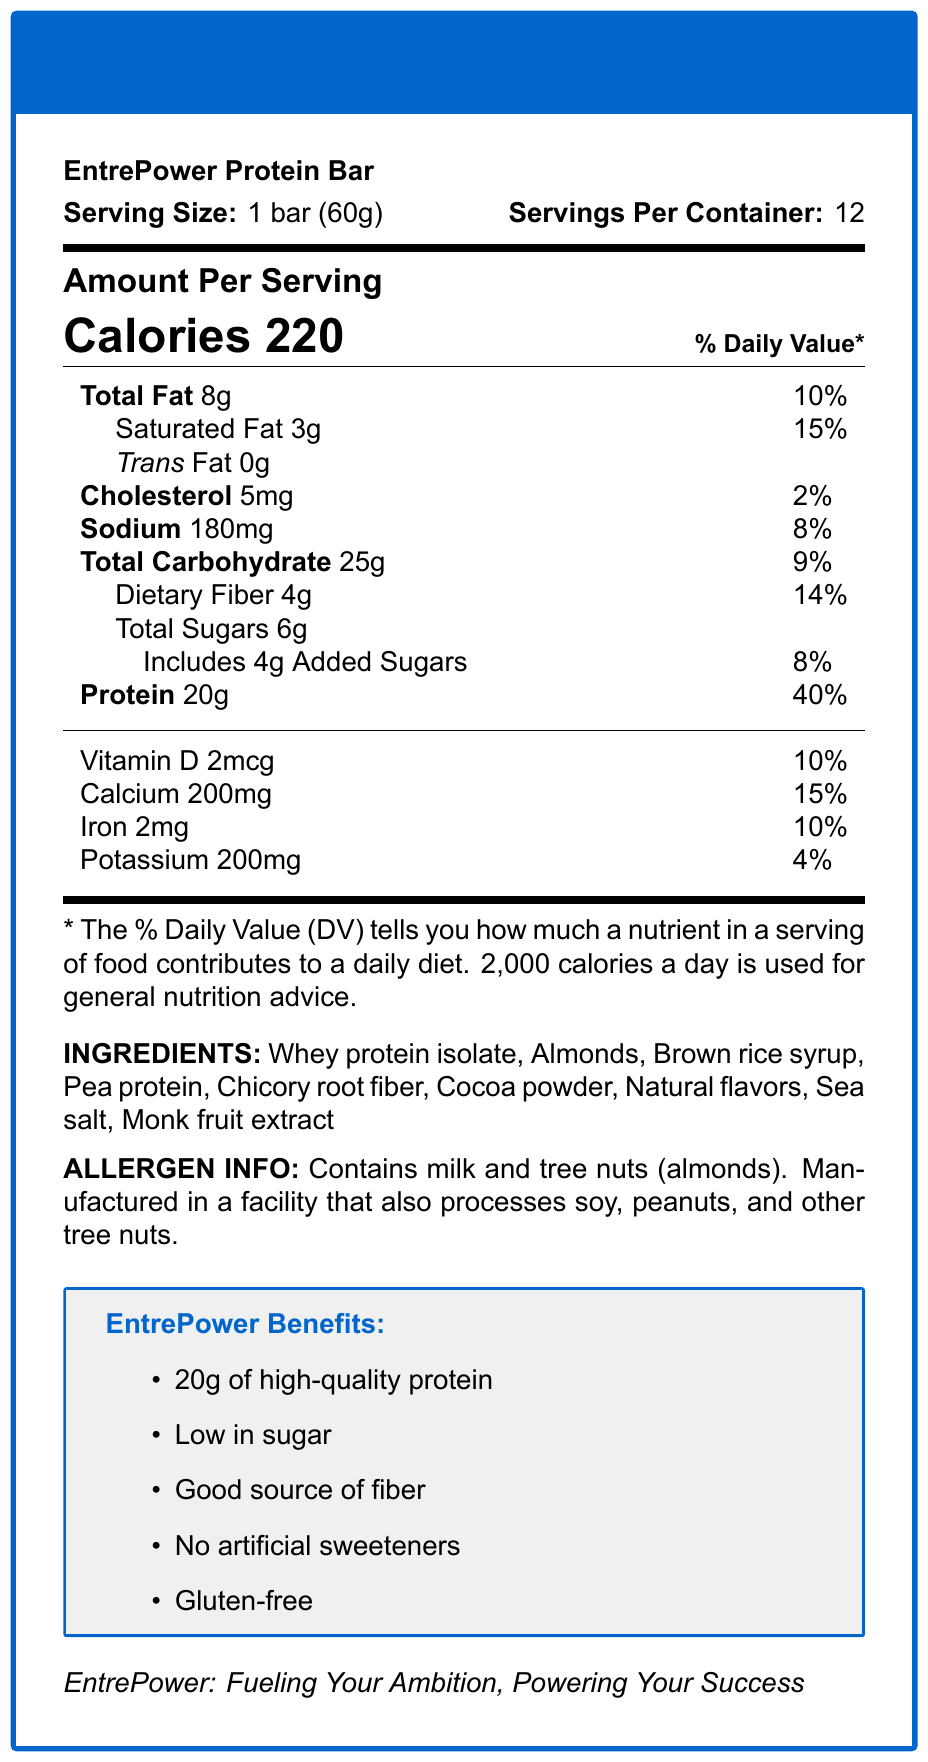what is the serving size of the EntrePower Protein Bar? The serving size is directly stated in the document: "Serving Size: 1 bar (60g)".
Answer: 1 bar (60g) how many servings are there per container? The document states, "Servings Per Container: 12".
Answer: 12 how many calories are in one serving of the EntrePower Protein Bar? The document mentions, "Calories 220" under the "Amount Per Serving" section.
Answer: 220 what is the amount of protein in one serving of the EntrePower Protein Bar? The "Protein" value listed under "Amount Per Serving" states "20g".
Answer: 20g how much dietary fiber does one bar contain? The "Dietary Fiber" listed under "Total Carbohydrate" states "4g".
Answer: 4g What percent of the daily value for calcium does one bar provide? A. 10% B. 15% C. 20% D. 25% The "Calcium" value is listed as "200mg" which is annotated with a "15%" daily value.
Answer: B what are the two main allergens listed in the allergen information? A. Eggs and Milk B. Milk and Tree Nuts C. Soy and Peanuts D. Wheat and Tree Nuts The allergen info states "Contains milk and tree nuts (almonds)".
Answer: B does the EntrePower Protein Bar contain any trans fat? The document explicitly states "Trans Fat 0g".
Answer: No is the EntrePower Protein Bar gluten-free? Under the Benefits section, it states "Gluten-free".
Answer: Yes what are the main benefits of the EntrePower Protein Bar? These benefits are listed under the section titled "EntrePower Benefits".
Answer: 20g of high-quality protein, Low in sugar, Good source of fiber, No artificial sweeteners, Gluten-free what is the daily value percentage of added sugars in one bar? The "Includes 4g Added Sugars" line lists the daily value as "8%".
Answer: 8% what key nutrients contribute to muscle recovery and maintenance? The key benefit of "Supports muscle recovery and maintenance" is primarily because of the high protein content which is 20g with a daily value of 40%.
Answer: Protein what target audience is the EntrePower Protein Bar designed for? The document mentions the target audience as "Busy entrepreneurs and professionals".
Answer: Busy entrepreneurs and professionals which ingredient is a natural sweetener in the EntrePower Protein Bar? Among the listed ingredients, monk fruit extract is a known natural sweetener.
Answer: Monk fruit extract how much Vitamin D does the EntrePower Protein Bar provide? The table listing vitamins and minerals states "Vitamin D 2mcg".
Answer: 2mcg Summarize the main idea of the EntrePower Protein Bar document. The document outlines the nutritional profile, ingredients, and benefits of the EntrePower Protein Bar while emphasizing its suitability for busy professionals.
Answer: The document provides detailed nutritional information about the EntrePower Protein Bar. It describes the serving size, number of servings per container, calories, macronutrient content, vitamins, minerals, ingredients, allergen information, key benefits, and targeted audience. The protein bar is designed to provide high-quality nutrition for busy entrepreneurs and professionals to support energy, mental focus, muscle recovery, and convenience. what specific natural flavors are used in the EntrePower Protein Bar? The document lists "Natural flavors" as an ingredient but does not specify what those natural flavors are.
Answer: Not enough information 